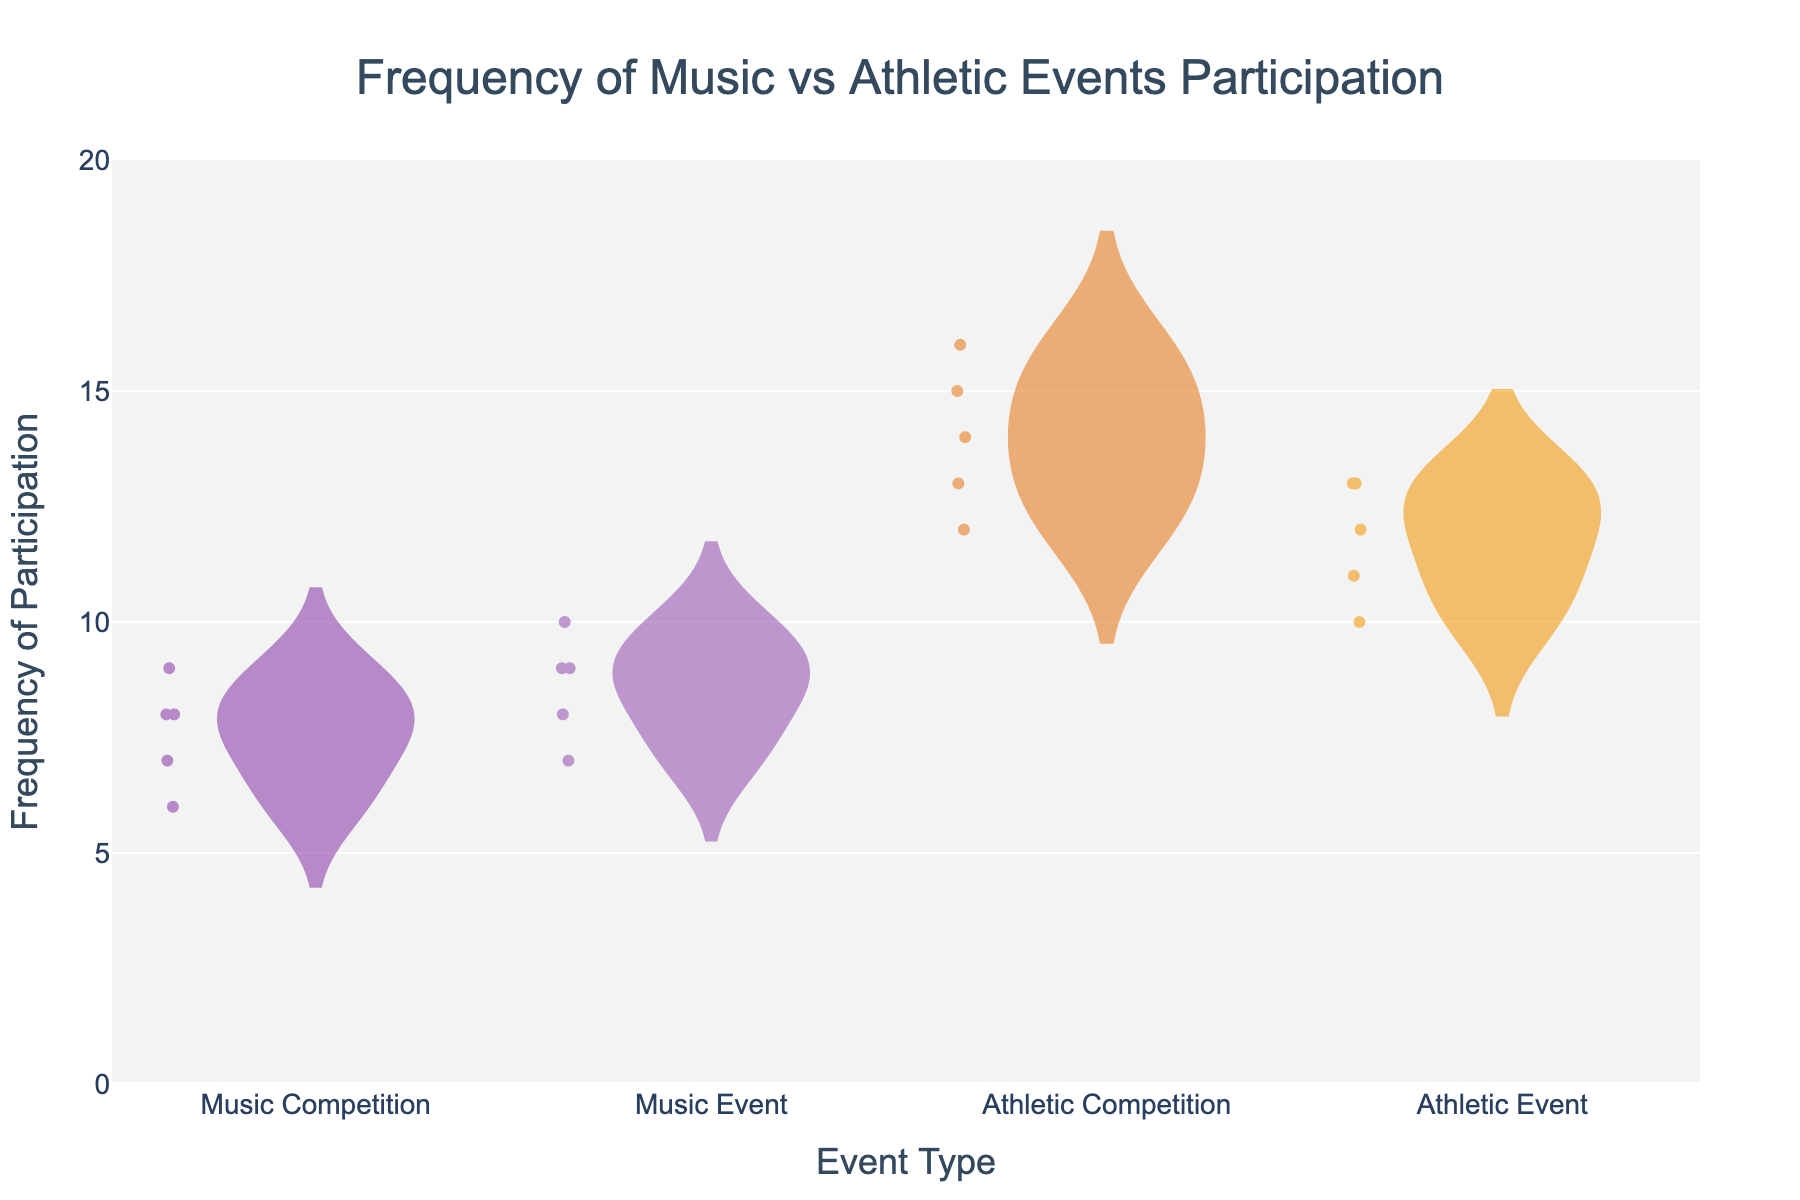What is the title of the density plot? The title is displayed at the top of the plot and provides a summary of what the plot is about.
Answer: Frequency of Music vs Athletic Events Participation What are the labels on the x-axis and y-axis? The x-axis and y-axis labels are found at the bottom and side of the plot, respectively. They describe what each axis represents.
Answer: Event Type and Frequency of Participation How many different event types are shown in the plot? The different event types are categorized along the x-axis.
Answer: Four Which event type shows the highest mean frequency of participation? The mean participation frequency is indicated by the mean line within each violin plot.
Answer: Athletic Competition What's the range of frequencies for Music Competitions? The range can be observed by looking at the spread of data points in the violin plot for Music Competitions. The lowest and highest points show the range.
Answer: 6 to 9 How do the frequencies of participation in Music Events compare to Athletic Events? This requires comparing the distribution shapes, spreads, and median lines of Music Events and Athletic Events. Music Events have a narrower spread and lower median frequency.
Answer: Music Events generally have lower frequencies than Athletic Events What is the median frequency of participation for Athletic Competitions? The median is represented by the thick line at the center of the violin. Look for the Athletic Competition category.
Answer: 14 How does the variability in participation frequencies compare between Music-related events and Athletic-related events? This requires comparing the spread (or variability) of the density plots for music events and athletic events. Athletic events show higher variability, as indicated by a wider spread of the violin plots.
Answer: Greater variability in Athletic events Which event type has the smallest interquartile range (IQR)? The IQR can be visually estimated by looking at the "box" part of the violin plot, which represents where the middle 50% of data points lie. The Music Event has the smallest IQR since its box is narrower.
Answer: Music Event Are there any outliers in the frequencies for any event type? Outliers are often represented by individual points that lie far outside the general spread of the data.
Answer: No 